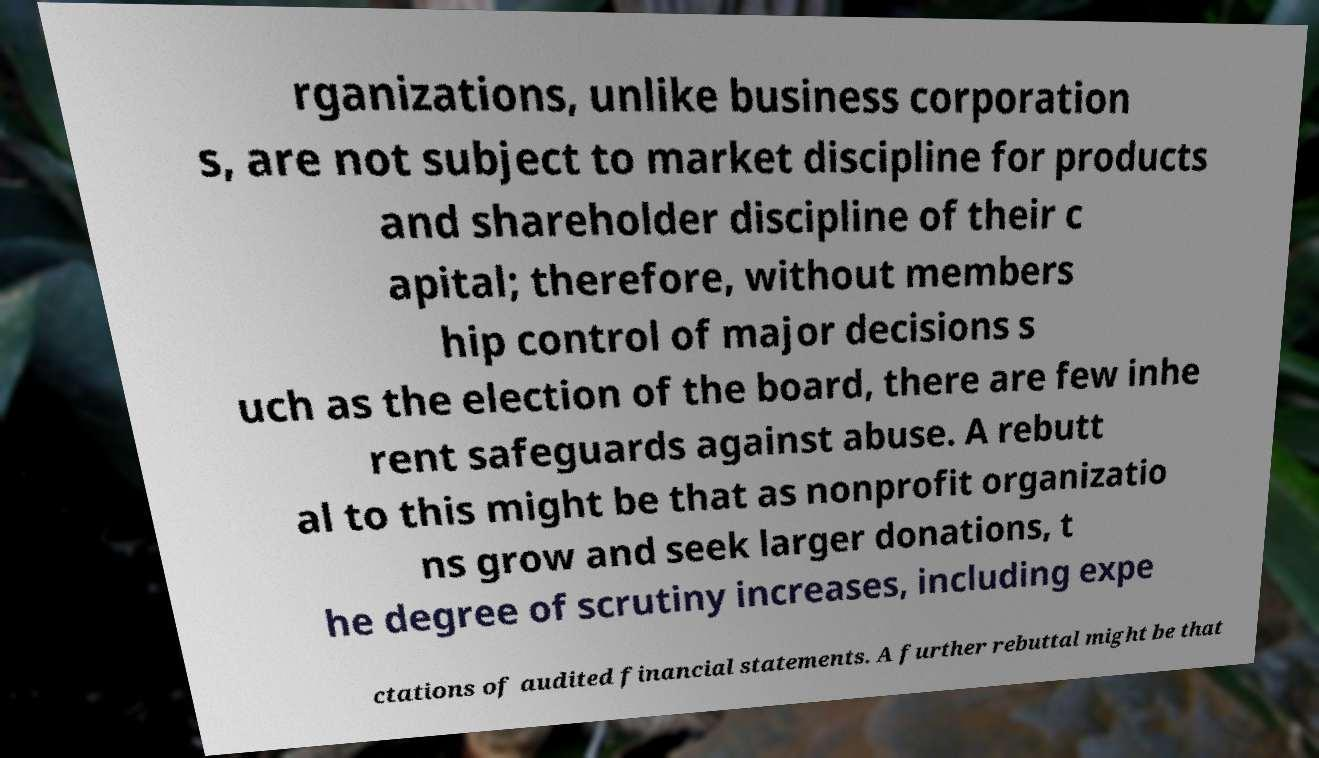Could you extract and type out the text from this image? rganizations, unlike business corporation s, are not subject to market discipline for products and shareholder discipline of their c apital; therefore, without members hip control of major decisions s uch as the election of the board, there are few inhe rent safeguards against abuse. A rebutt al to this might be that as nonprofit organizatio ns grow and seek larger donations, t he degree of scrutiny increases, including expe ctations of audited financial statements. A further rebuttal might be that 